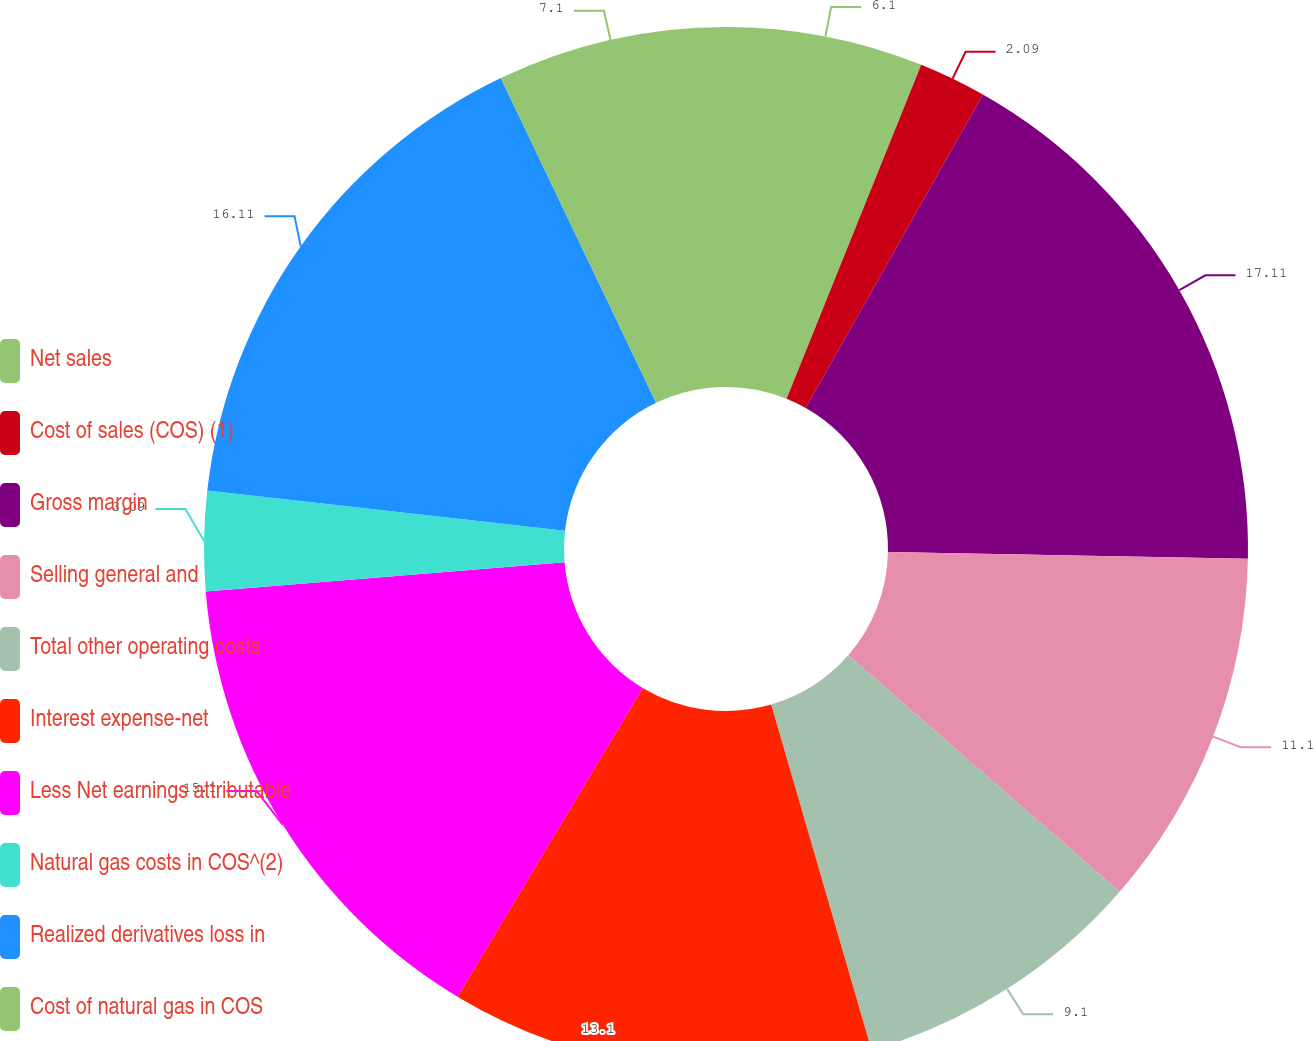Convert chart to OTSL. <chart><loc_0><loc_0><loc_500><loc_500><pie_chart><fcel>Net sales<fcel>Cost of sales (COS) (1)<fcel>Gross margin<fcel>Selling general and<fcel>Total other operating costs<fcel>Interest expense-net<fcel>Less Net earnings attributable<fcel>Natural gas costs in COS^(2)<fcel>Realized derivatives loss in<fcel>Cost of natural gas in COS<nl><fcel>6.1%<fcel>2.09%<fcel>17.11%<fcel>11.1%<fcel>9.1%<fcel>13.1%<fcel>15.1%<fcel>3.09%<fcel>16.11%<fcel>7.1%<nl></chart> 